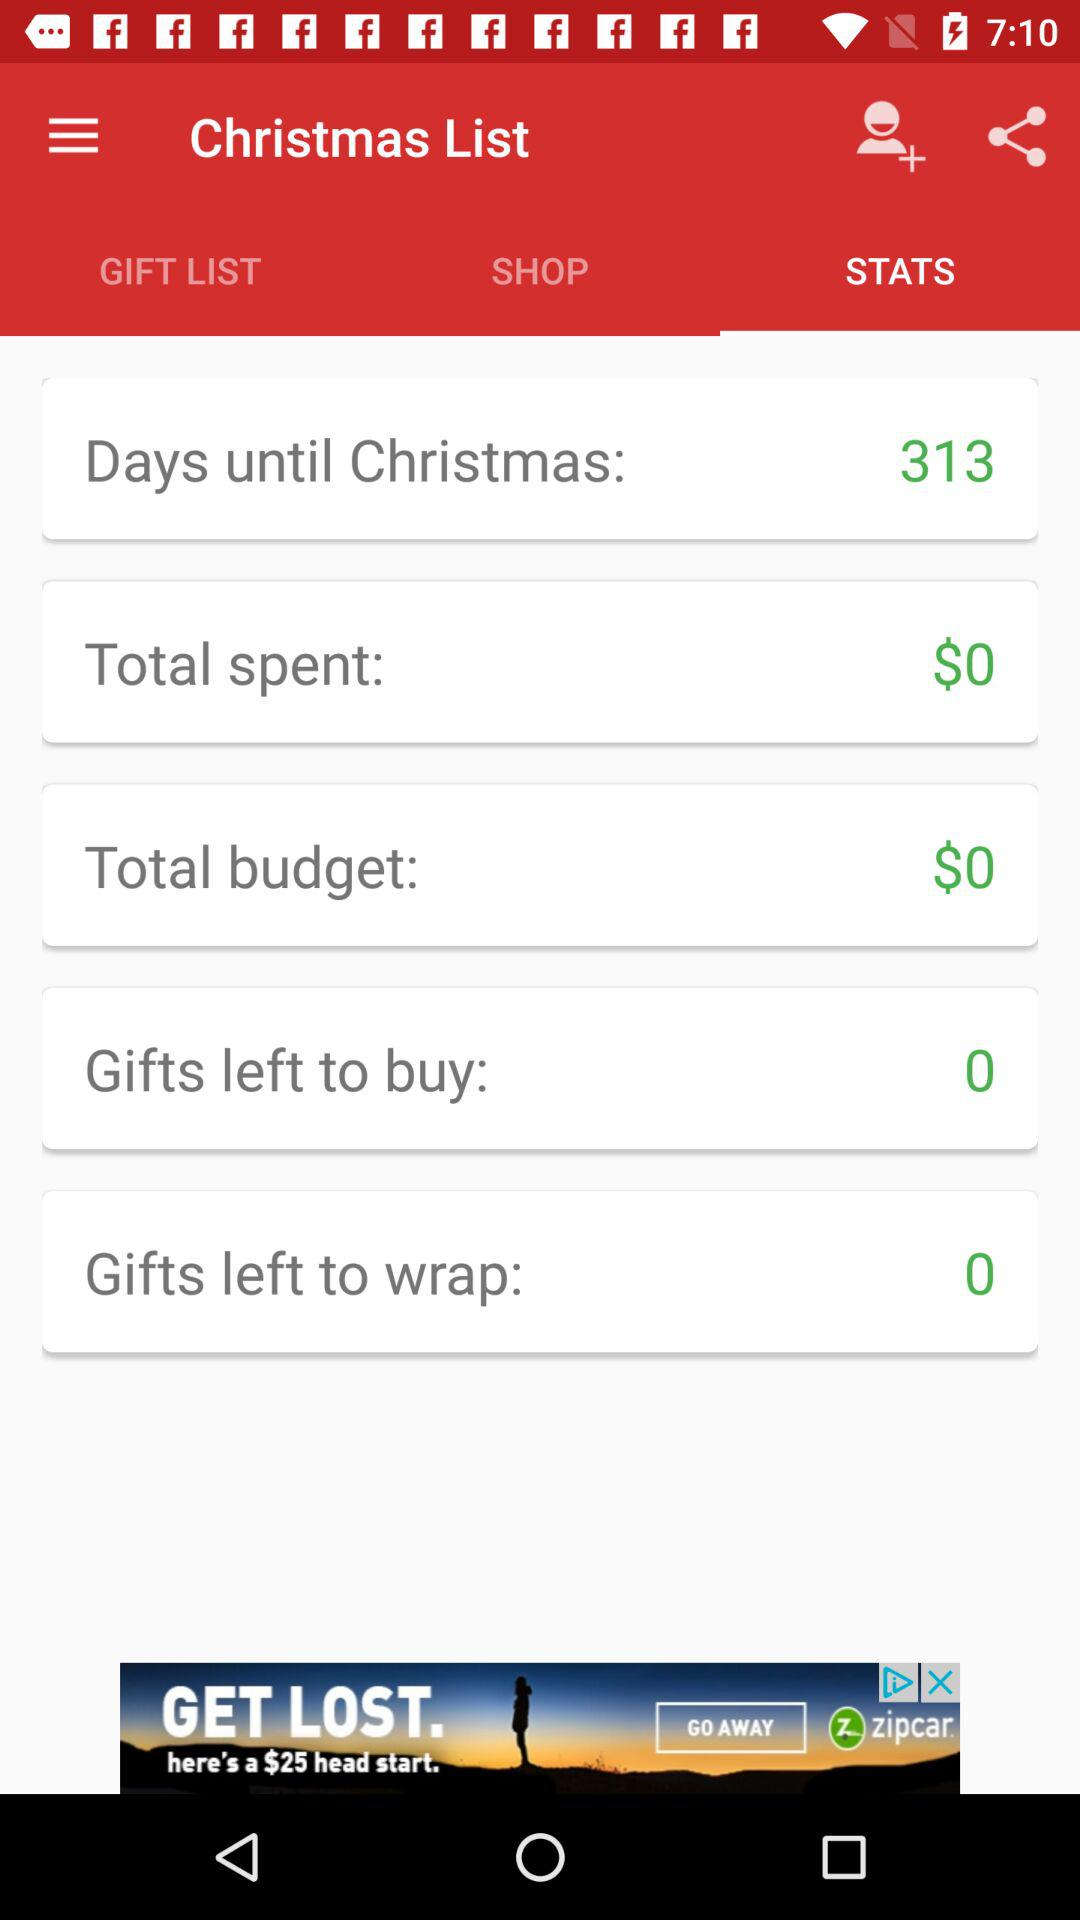Which tab is selected? The selected tab is "STATS". 